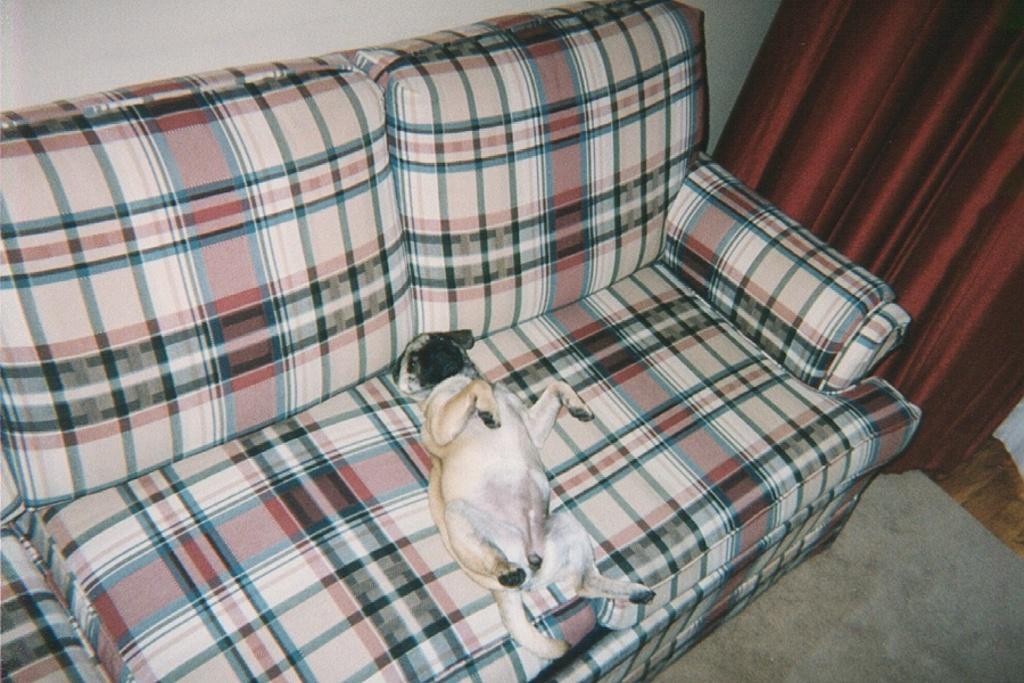Describe this image in one or two sentences. In this image we can see a dog on a sofa. On the right side there is a curtain. On the floor there is a carpet. In the back there is a wall. 